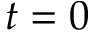Convert formula to latex. <formula><loc_0><loc_0><loc_500><loc_500>t = 0</formula> 